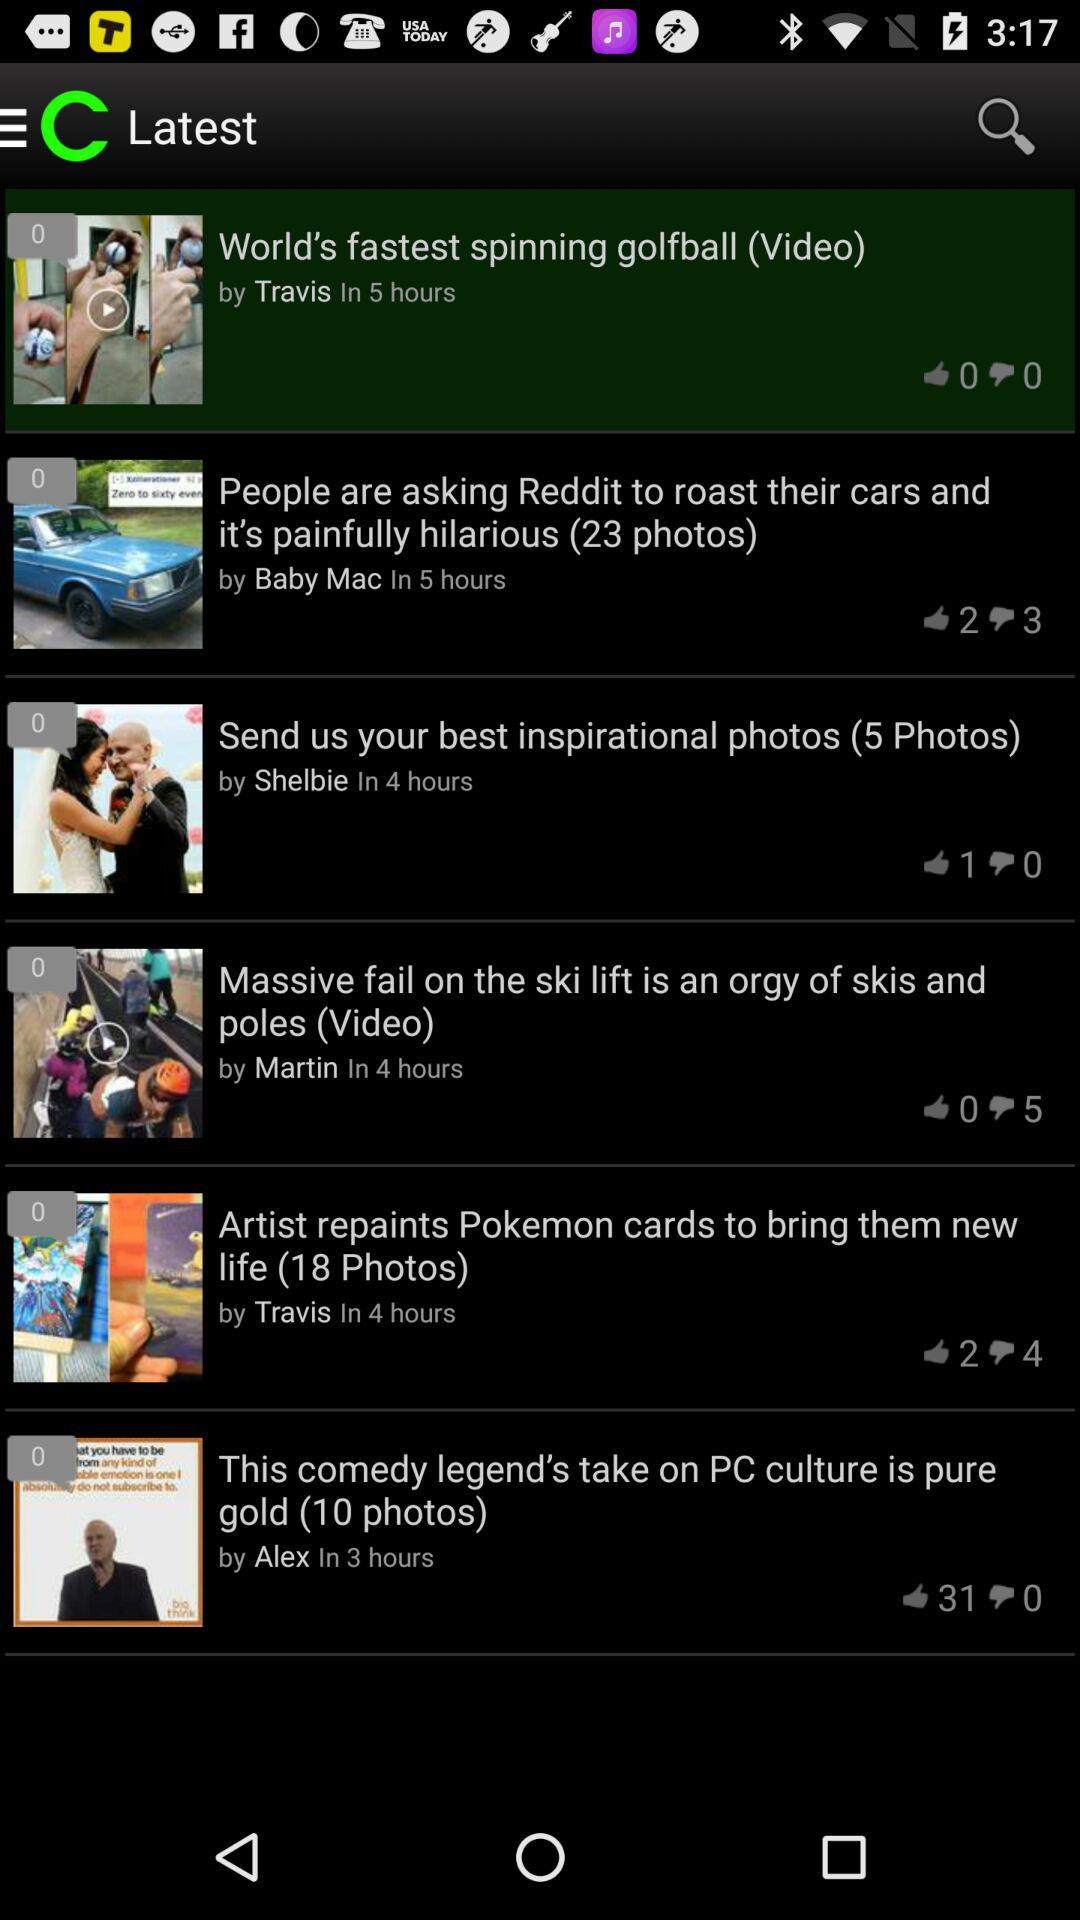How many people have liked the "Send us your best inspirational photos" post? There is 1 person who has liked the "Send us your best inspirational photos" post. 